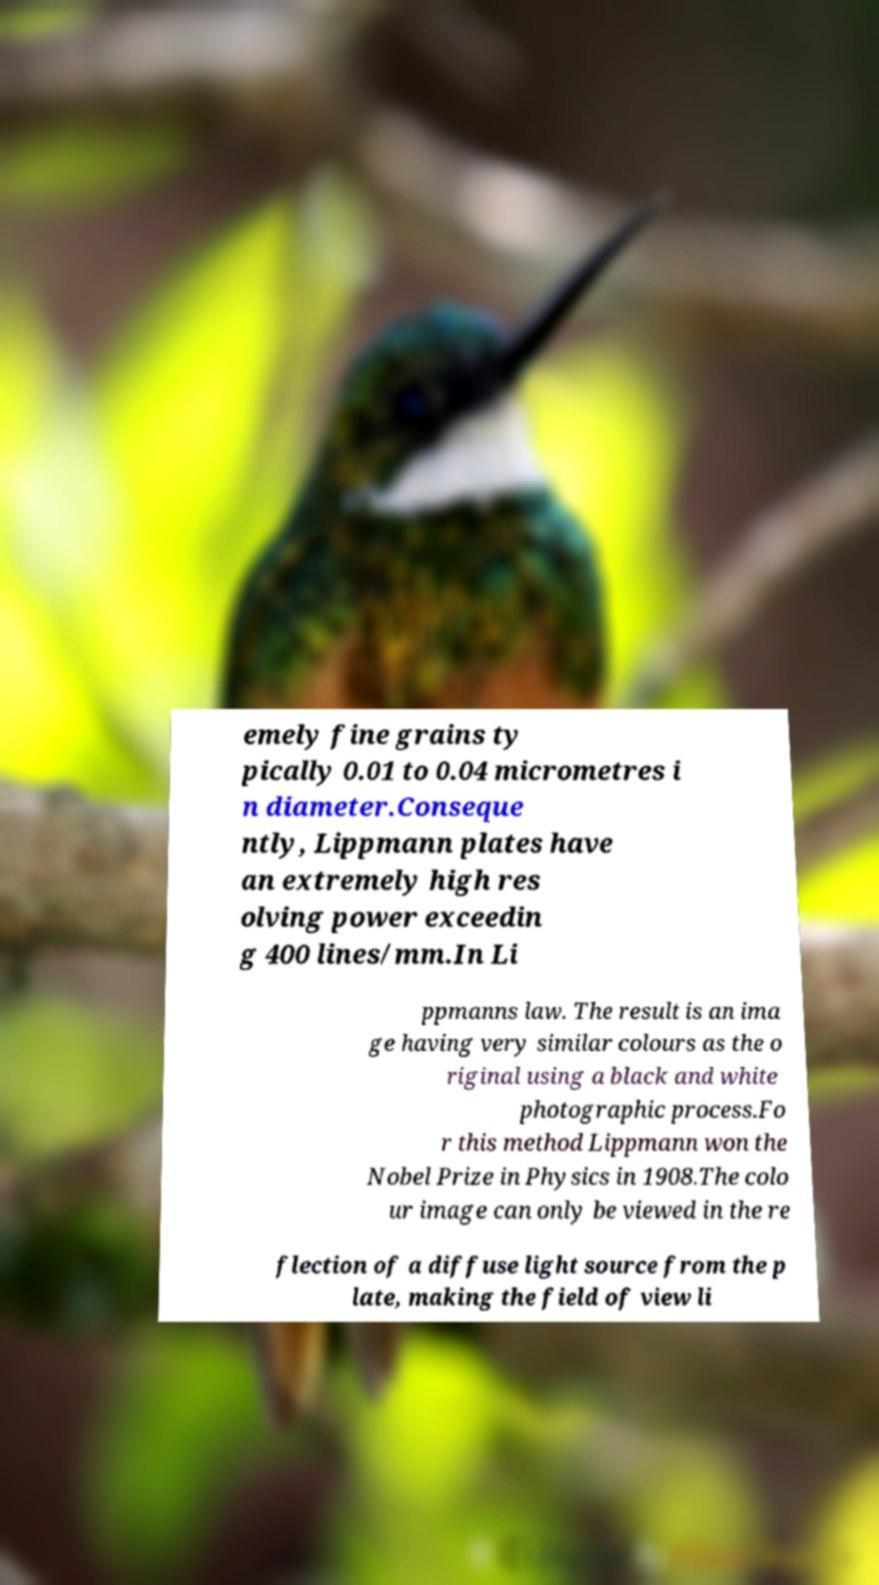I need the written content from this picture converted into text. Can you do that? emely fine grains ty pically 0.01 to 0.04 micrometres i n diameter.Conseque ntly, Lippmann plates have an extremely high res olving power exceedin g 400 lines/mm.In Li ppmanns law. The result is an ima ge having very similar colours as the o riginal using a black and white photographic process.Fo r this method Lippmann won the Nobel Prize in Physics in 1908.The colo ur image can only be viewed in the re flection of a diffuse light source from the p late, making the field of view li 